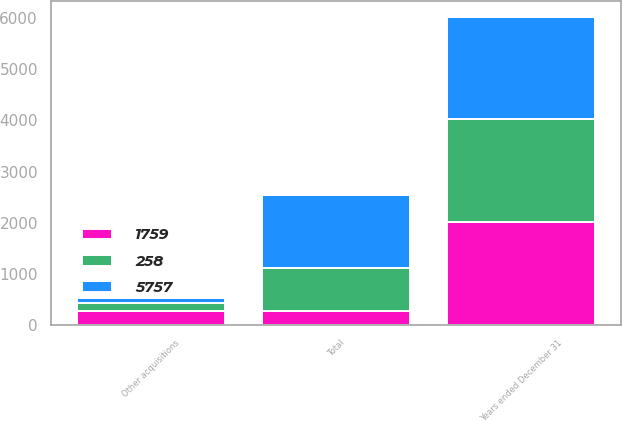<chart> <loc_0><loc_0><loc_500><loc_500><stacked_bar_chart><ecel><fcel>Years ended December 31<fcel>Other acquisitions<fcel>Total<nl><fcel>258<fcel>2010<fcel>157<fcel>846<nl><fcel>1759<fcel>2009<fcel>274<fcel>274<nl><fcel>5757<fcel>2008<fcel>105<fcel>1418<nl></chart> 